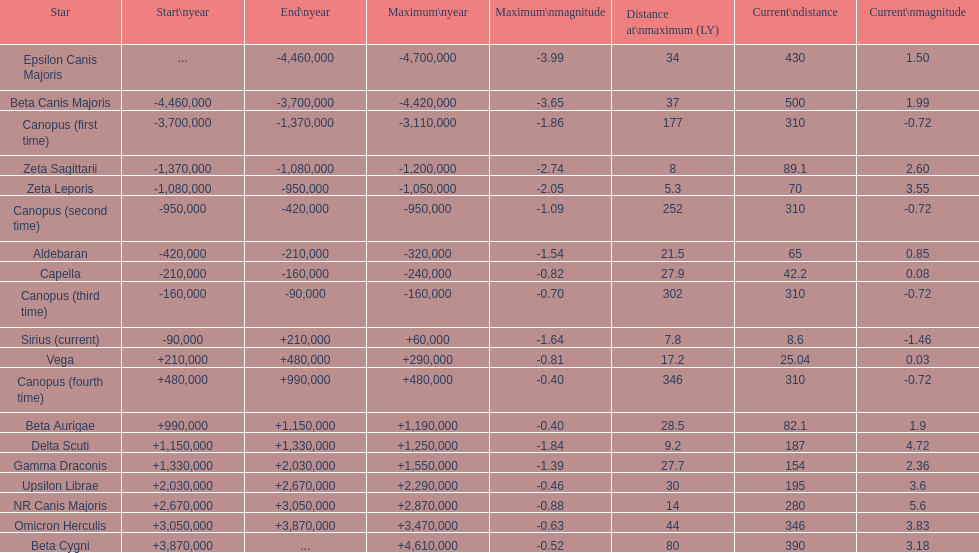How many stars possess a current magnitude not surpassing zero? 5. 